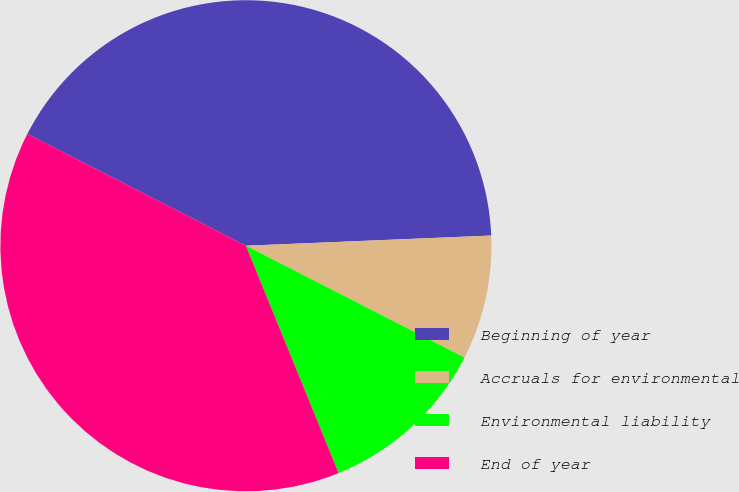<chart> <loc_0><loc_0><loc_500><loc_500><pie_chart><fcel>Beginning of year<fcel>Accruals for environmental<fcel>Environmental liability<fcel>End of year<nl><fcel>41.81%<fcel>8.19%<fcel>11.31%<fcel>38.69%<nl></chart> 